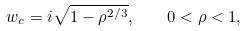<formula> <loc_0><loc_0><loc_500><loc_500>w _ { c } = i \sqrt { 1 - \rho ^ { 2 / 3 } } , \quad 0 < \rho < 1 ,</formula> 